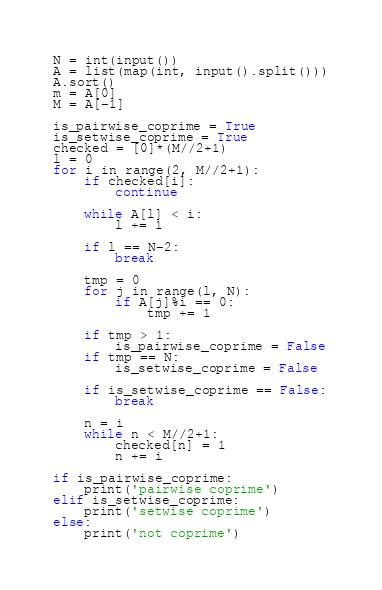<code> <loc_0><loc_0><loc_500><loc_500><_Python_>N = int(input())
A = list(map(int, input().split()))
A.sort()
m = A[0]
M = A[-1]

is_pairwise_coprime = True
is_setwise_coprime = True
checked = [0]*(M//2+1)
l = 0
for i in range(2, M//2+1):
    if checked[i]:
        continue
    
    while A[l] < i:
        l += 1
    
    if l == N-2:
        break
    
    tmp = 0
    for j in range(l, N):
        if A[j]%i == 0:
            tmp += 1
    
    if tmp > 1:
        is_pairwise_coprime = False
    if tmp == N:
        is_setwise_coprime = False
    
    if is_setwise_coprime == False:
        break
    
    n = i
    while n < M//2+1:
        checked[n] = 1
        n += i

if is_pairwise_coprime:
    print('pairwise coprime')
elif is_setwise_coprime:
    print('setwise coprime')
else:
    print('not coprime')</code> 